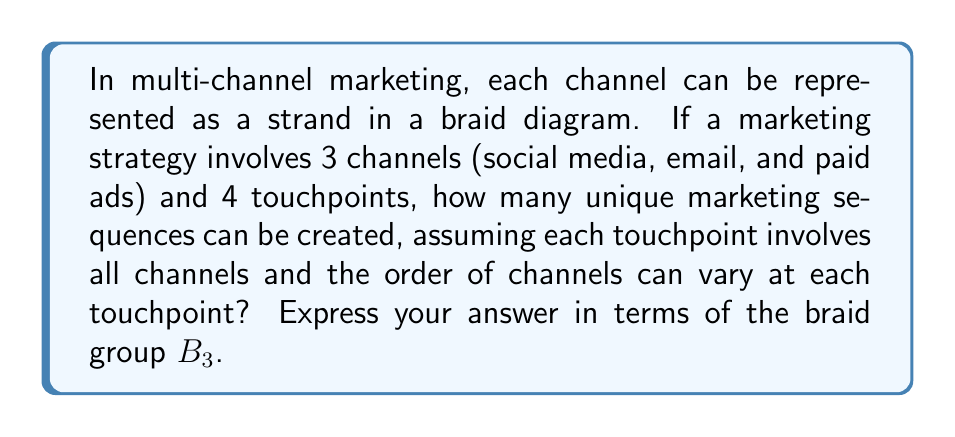Give your solution to this math problem. Let's approach this step-by-step:

1) In braid theory, we're working with the braid group $B_3$ since we have 3 channels (strands).

2) Each touchpoint represents a level in the braid diagram where crossings can occur.

3) At each level, we have $3! = 6$ possible arrangements of the 3 strands, corresponding to the 6 elements of $S_3$ (the symmetric group on 3 elements).

4) These 6 arrangements correspond to the following elements of $B_3$:
   - Identity: $e$
   - Simple crossings: $\sigma_1$, $\sigma_2$, $\sigma_1^{-1}$, $\sigma_2^{-1}$
   - Full twist: $\sigma_1\sigma_2\sigma_1$ (or equivalently, $\sigma_2\sigma_1\sigma_2$)

5) For each of the 4 touchpoints, we can independently choose any of these 6 arrangements.

6) By the fundamental counting principle, the total number of unique sequences is:

   $$ 6^4 = 1296 $$

7) In terms of the braid group $B_3$, this means we're counting all possible products of 4 elements from the set $\{e, \sigma_1, \sigma_2, \sigma_1^{-1}, \sigma_2^{-1}, \sigma_1\sigma_2\sigma_1\}$.

8) Therefore, the number of unique marketing sequences can be expressed as the cardinality of this subset of $B_3$:

   $$ |\{w \in B_3 : w = w_1w_2w_3w_4, w_i \in \{e, \sigma_1, \sigma_2, \sigma_1^{-1}, \sigma_2^{-1}, \sigma_1\sigma_2\sigma_1\}\}| = 1296 $$
Answer: $1296$ or $|\{w \in B_3 : w = w_1w_2w_3w_4, w_i \in \{e, \sigma_1, \sigma_2, \sigma_1^{-1}, \sigma_2^{-1}, \sigma_1\sigma_2\sigma_1\}\}|$ 